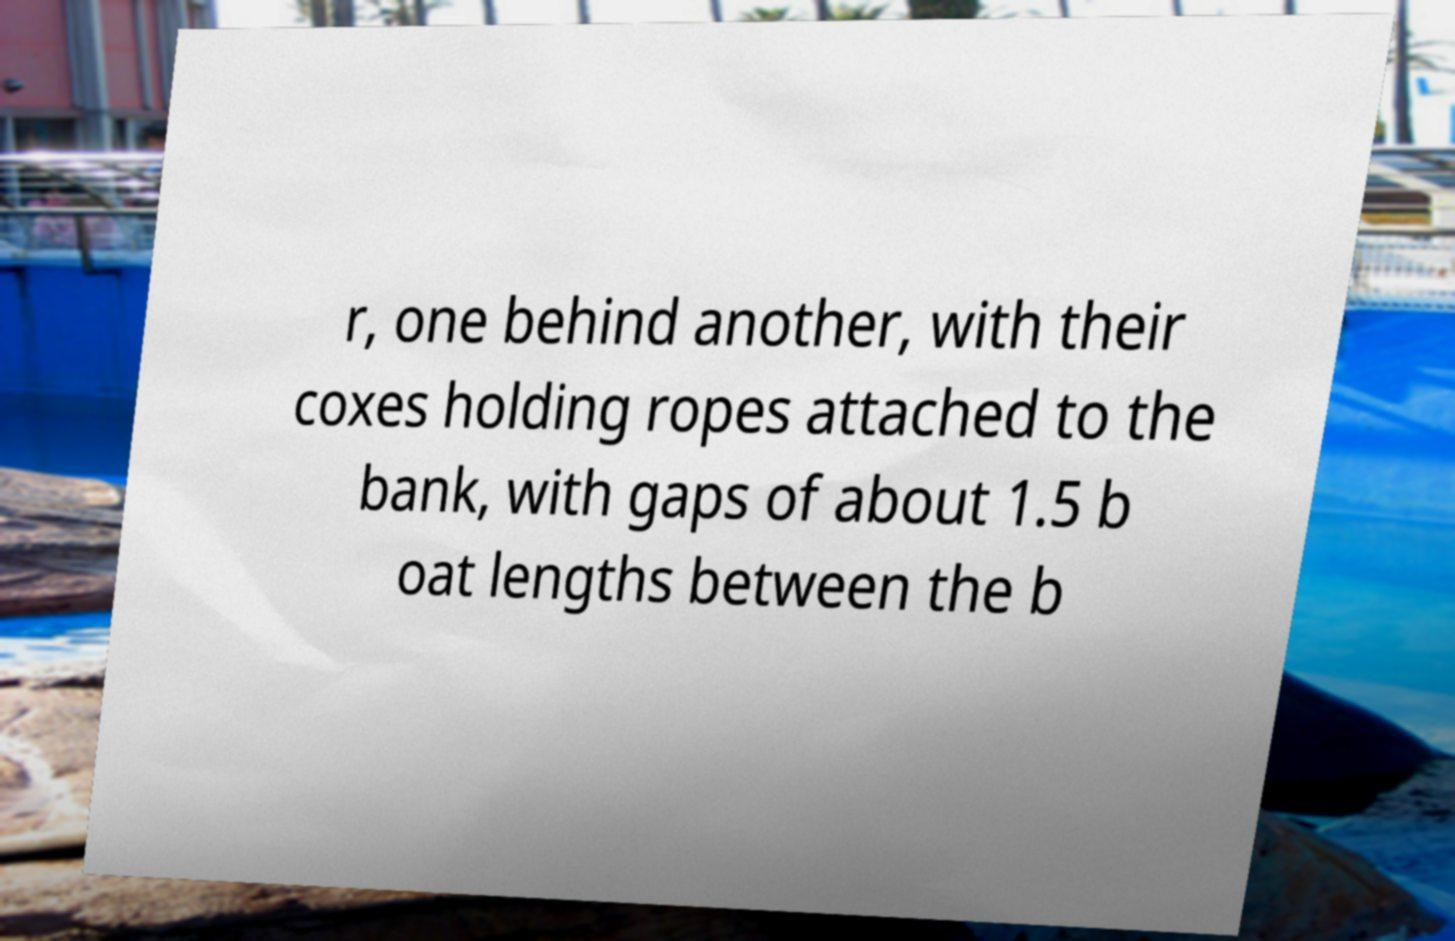Please read and relay the text visible in this image. What does it say? r, one behind another, with their coxes holding ropes attached to the bank, with gaps of about 1.5 b oat lengths between the b 